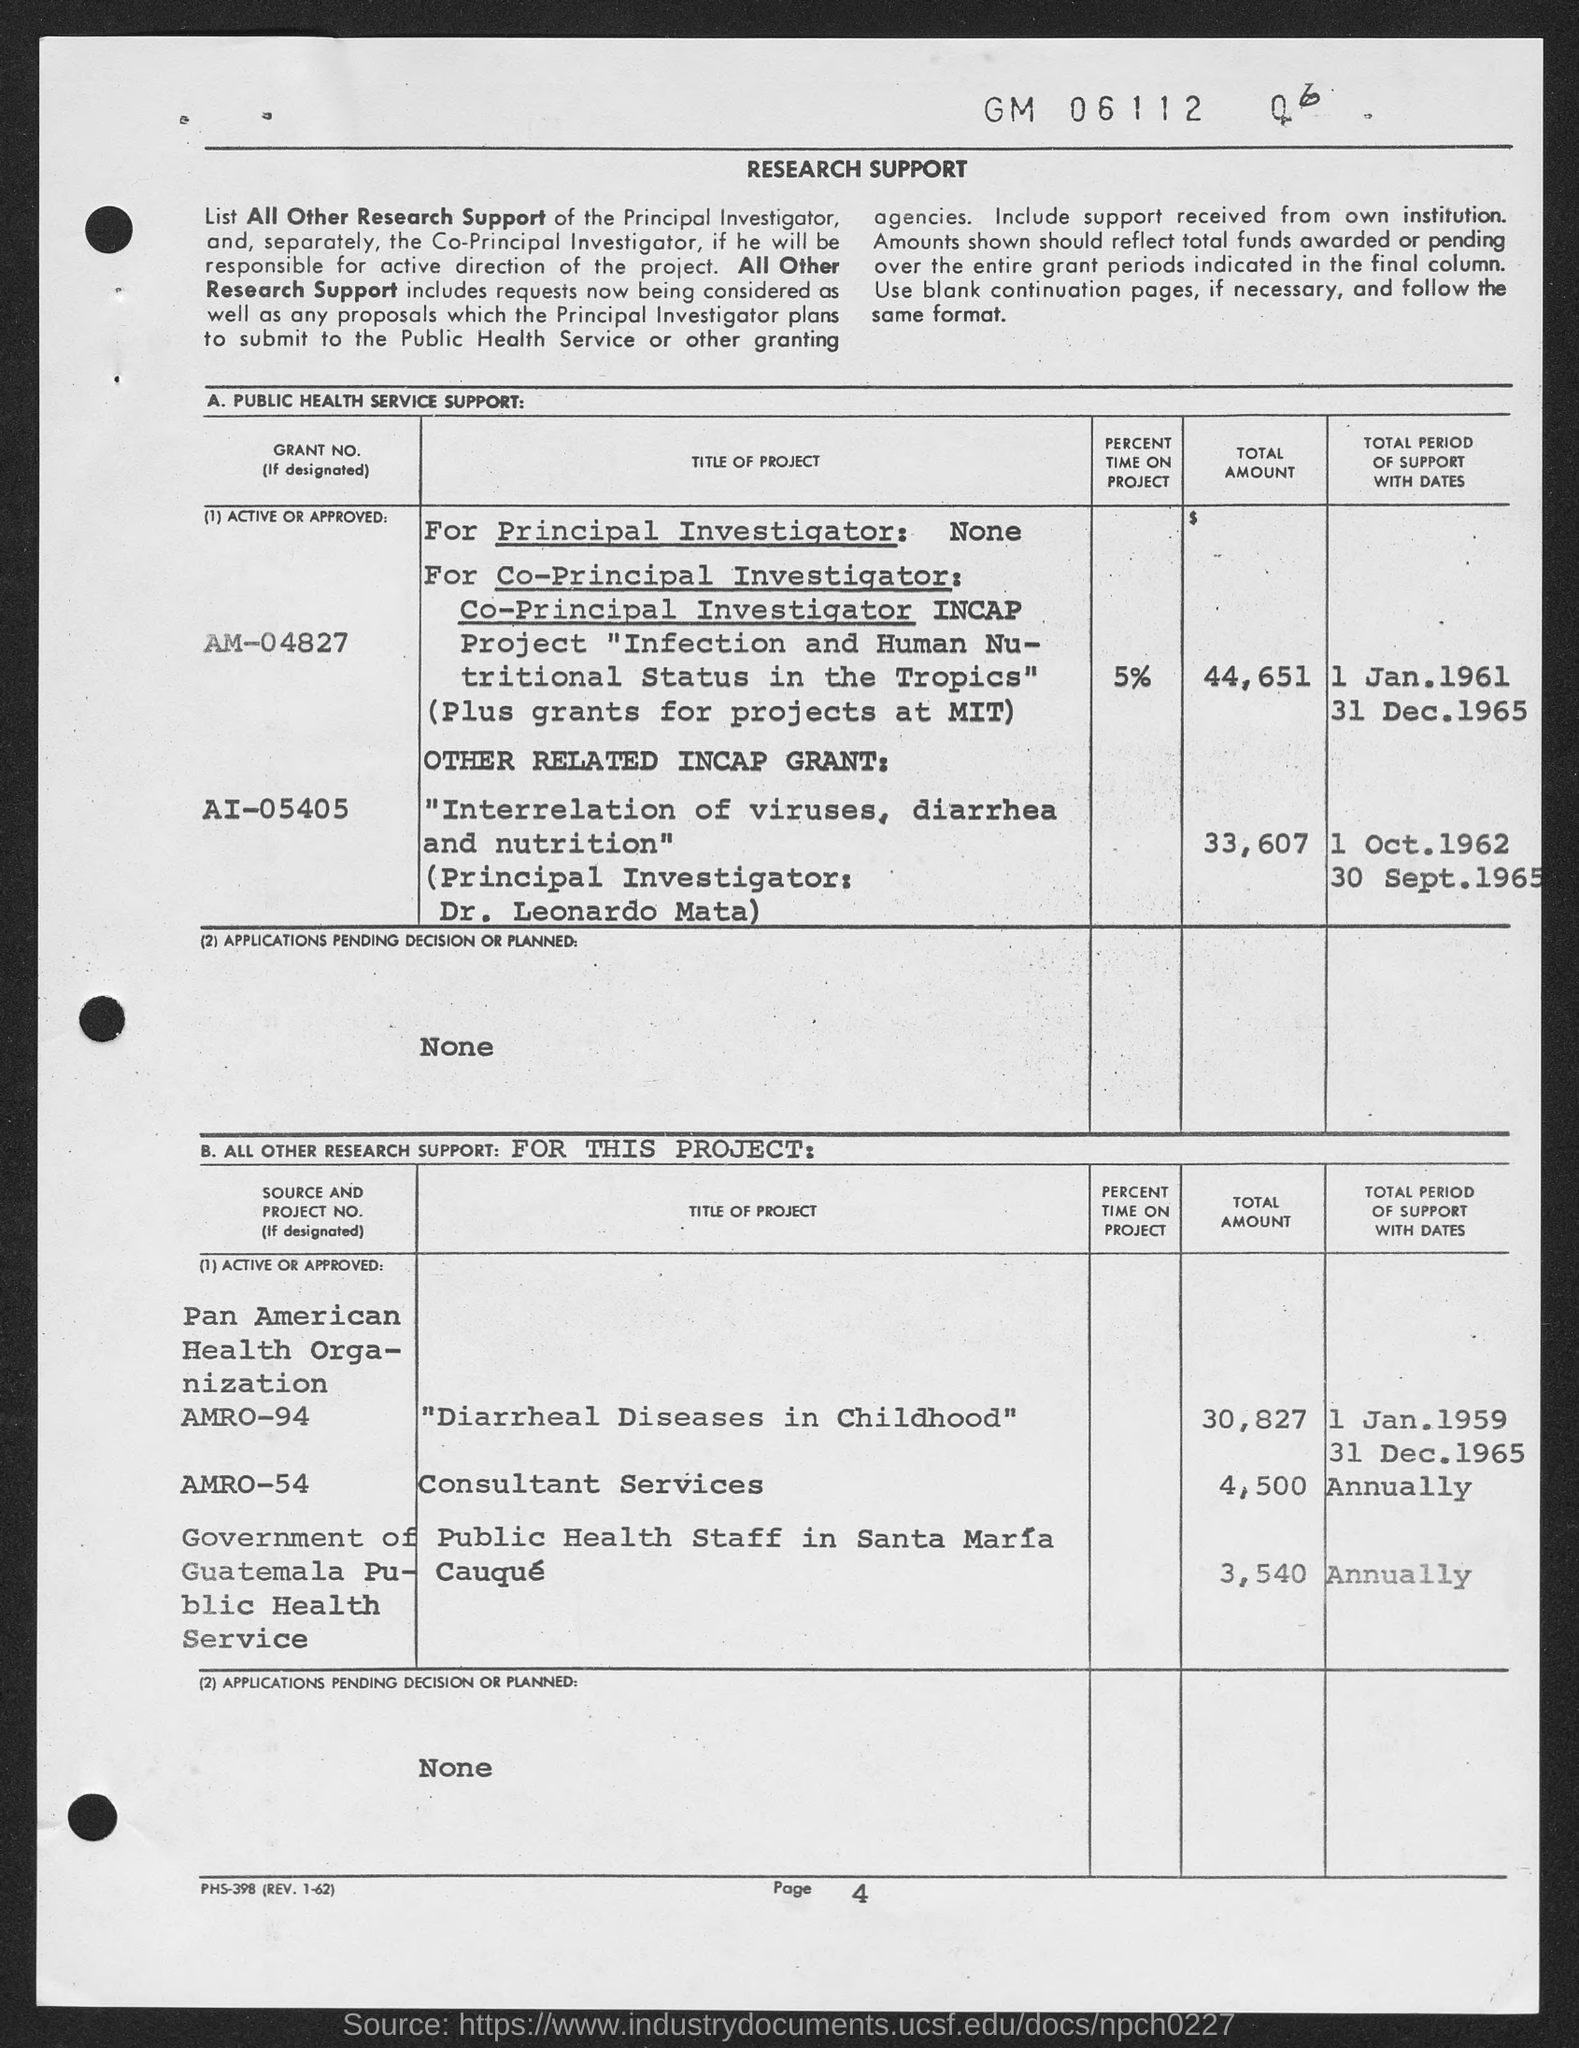Identify some key points in this picture. The page number at the bottom of the page is 4. 